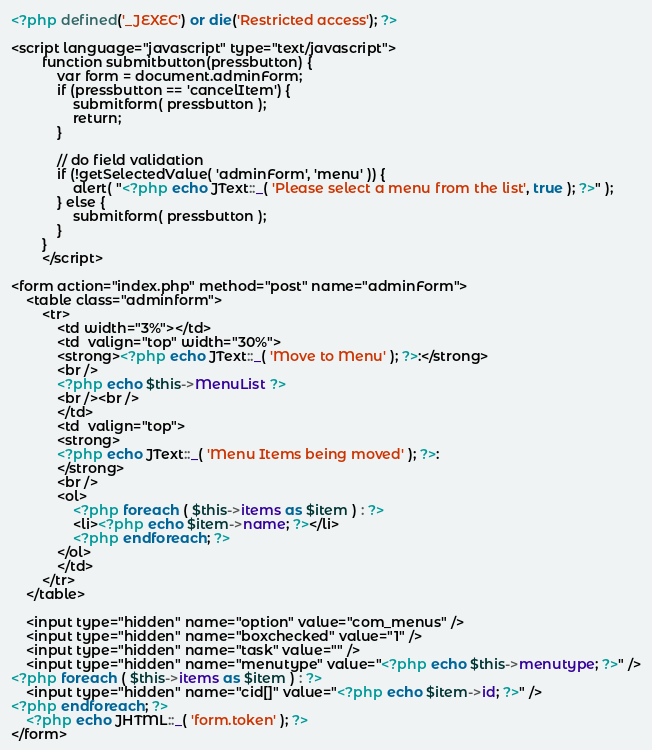Convert code to text. <code><loc_0><loc_0><loc_500><loc_500><_PHP_><?php defined('_JEXEC') or die('Restricted access'); ?>

<script language="javascript" type="text/javascript">
		function submitbutton(pressbutton) {
			var form = document.adminForm;
			if (pressbutton == 'cancelItem') {
				submitform( pressbutton );
				return;
			}

			// do field validation
			if (!getSelectedValue( 'adminForm', 'menu' )) {
				alert( "<?php echo JText::_( 'Please select a menu from the list', true ); ?>" );
			} else {
				submitform( pressbutton );
			}
		}
		</script>

<form action="index.php" method="post" name="adminForm">
	<table class="adminform">
		<tr>
			<td width="3%"></td>
			<td  valign="top" width="30%">
			<strong><?php echo JText::_( 'Move to Menu' ); ?>:</strong>
			<br />
			<?php echo $this->MenuList ?>
			<br /><br />
			</td>
			<td  valign="top">
			<strong>
			<?php echo JText::_( 'Menu Items being moved' ); ?>:
			</strong>
			<br />
			<ol>
				<?php foreach ( $this->items as $item ) : ?>
				<li><?php echo $item->name; ?></li>
				<?php endforeach; ?>
			</ol>
			</td>
		</tr>
	</table>

	<input type="hidden" name="option" value="com_menus" />
	<input type="hidden" name="boxchecked" value="1" />
	<input type="hidden" name="task" value="" />
	<input type="hidden" name="menutype" value="<?php echo $this->menutype; ?>" />
<?php foreach ( $this->items as $item ) : ?>
	<input type="hidden" name="cid[]" value="<?php echo $item->id; ?>" />
<?php endforeach; ?>
	<?php echo JHTML::_( 'form.token' ); ?>
</form>
</code> 